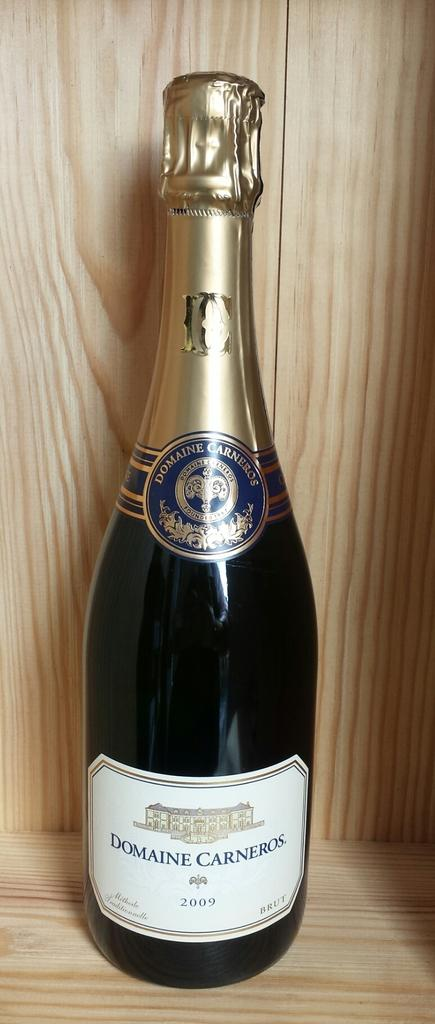<image>
Create a compact narrative representing the image presented. A single bottle of Domaine Carneros vintage 2009 champagne. 